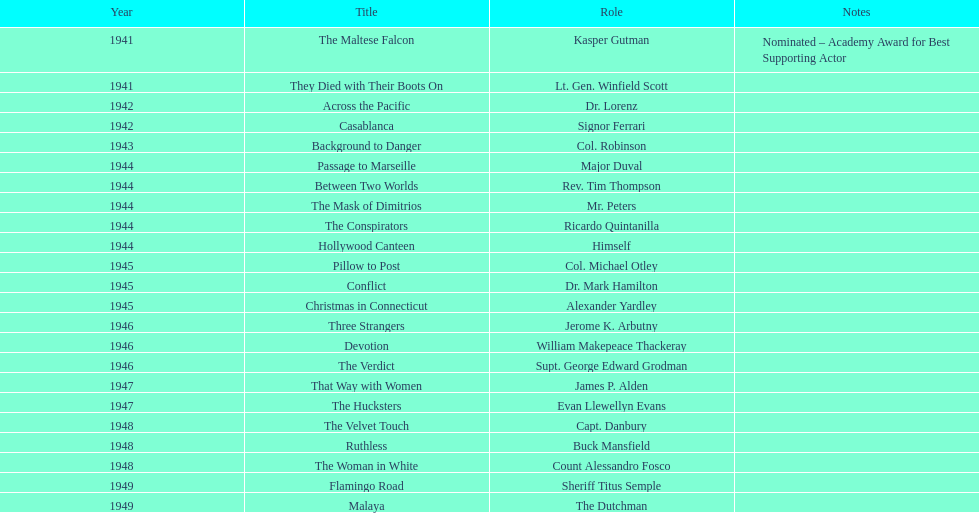What movies did greenstreet act for in 1946? Three Strangers, Devotion, The Verdict. 